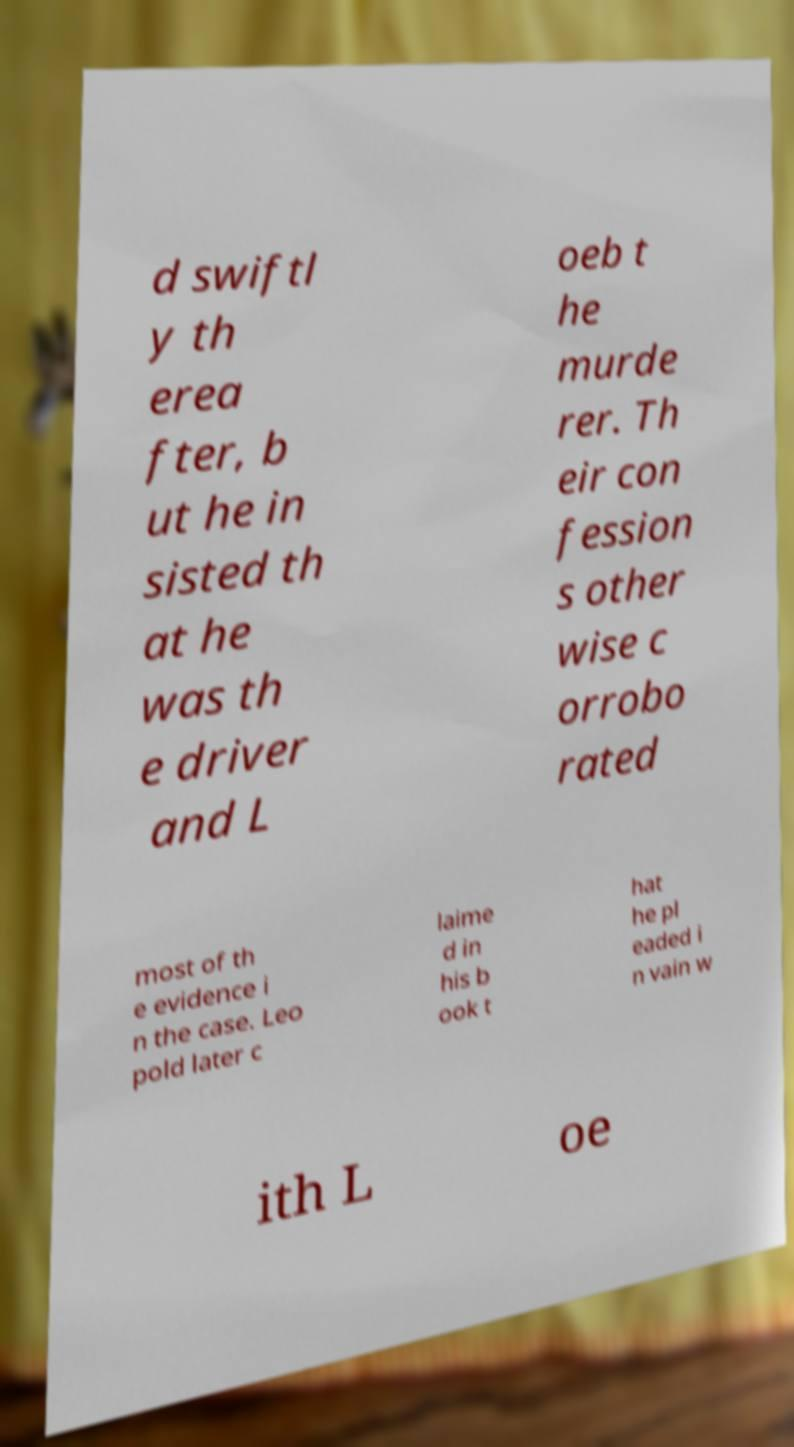Can you read and provide the text displayed in the image?This photo seems to have some interesting text. Can you extract and type it out for me? d swiftl y th erea fter, b ut he in sisted th at he was th e driver and L oeb t he murde rer. Th eir con fession s other wise c orrobo rated most of th e evidence i n the case. Leo pold later c laime d in his b ook t hat he pl eaded i n vain w ith L oe 